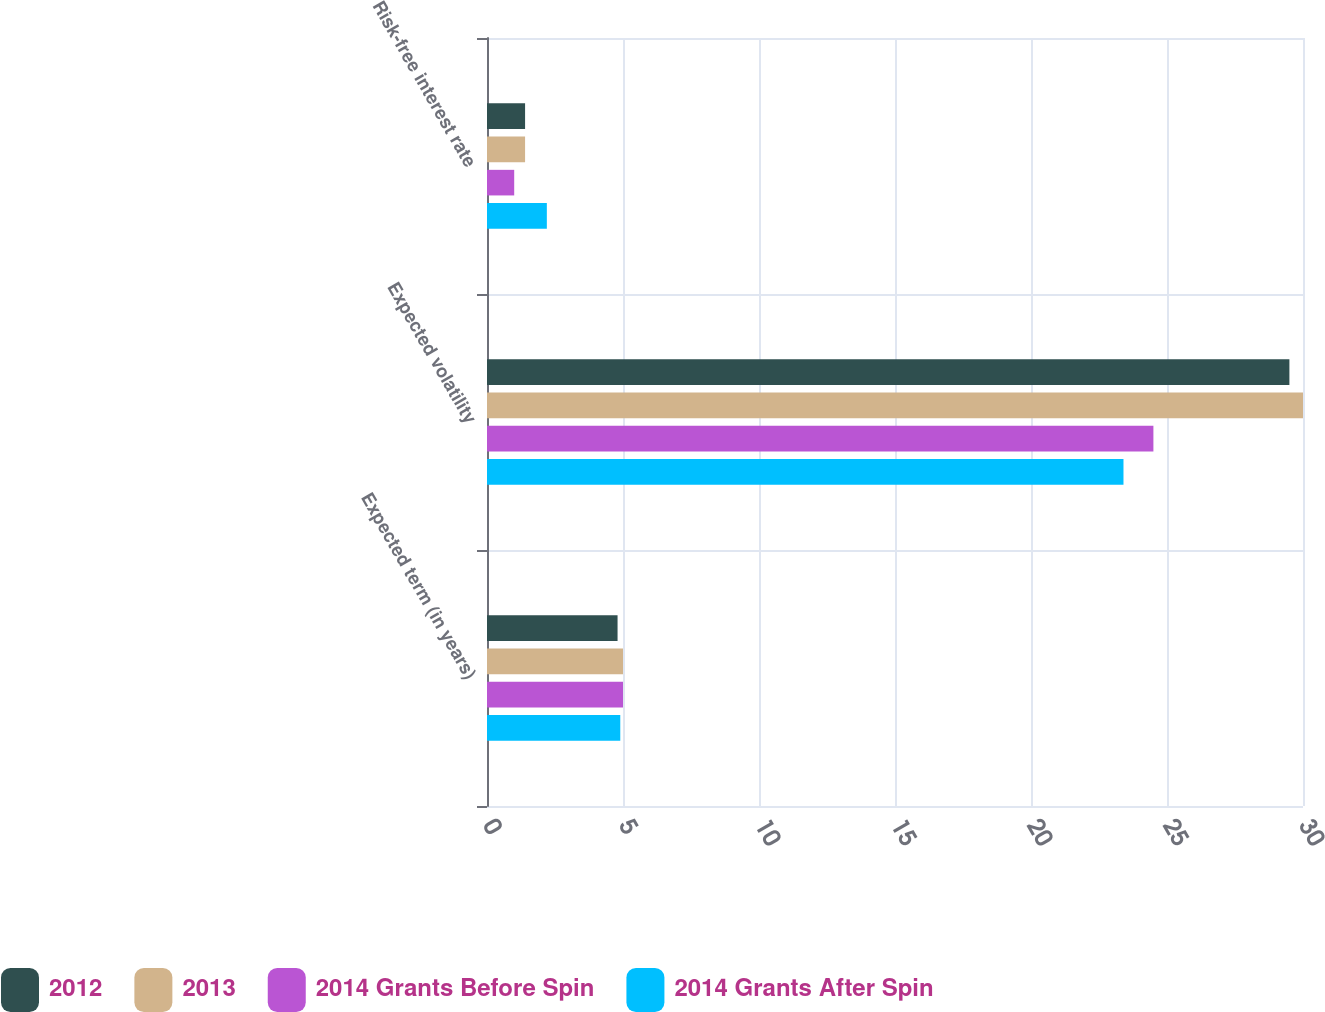Convert chart to OTSL. <chart><loc_0><loc_0><loc_500><loc_500><stacked_bar_chart><ecel><fcel>Expected term (in years)<fcel>Expected volatility<fcel>Risk-free interest rate<nl><fcel>2012<fcel>4.8<fcel>29.5<fcel>1.4<nl><fcel>2013<fcel>5<fcel>30<fcel>1.4<nl><fcel>2014 Grants Before Spin<fcel>5<fcel>24.5<fcel>1<nl><fcel>2014 Grants After Spin<fcel>4.9<fcel>23.4<fcel>2.2<nl></chart> 